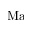<formula> <loc_0><loc_0><loc_500><loc_500>M a</formula> 